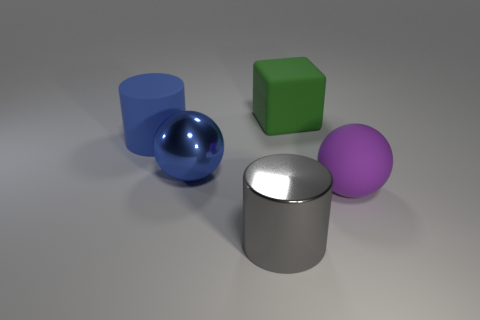What number of purple things have the same size as the purple rubber ball?
Ensure brevity in your answer.  0. Is the number of blue rubber cylinders that are behind the big rubber cylinder less than the number of big purple matte spheres that are on the left side of the green object?
Give a very brief answer. No. There is a blue object behind the big metallic thing behind the large cylinder in front of the large blue ball; how big is it?
Provide a short and direct response. Large. How big is the rubber thing that is both behind the matte ball and in front of the block?
Provide a succinct answer. Large. What is the shape of the matte thing in front of the cylinder behind the big gray metal object?
Keep it short and to the point. Sphere. Are there any other things that are the same color as the shiny cylinder?
Ensure brevity in your answer.  No. There is a matte thing that is on the left side of the big gray cylinder; what shape is it?
Make the answer very short. Cylinder. There is a large object that is on the right side of the shiny cylinder and behind the large purple rubber sphere; what shape is it?
Ensure brevity in your answer.  Cube. What number of yellow things are either rubber cubes or large matte spheres?
Offer a terse response. 0. Does the matte thing in front of the big blue matte cylinder have the same color as the metal sphere?
Your answer should be very brief. No. 